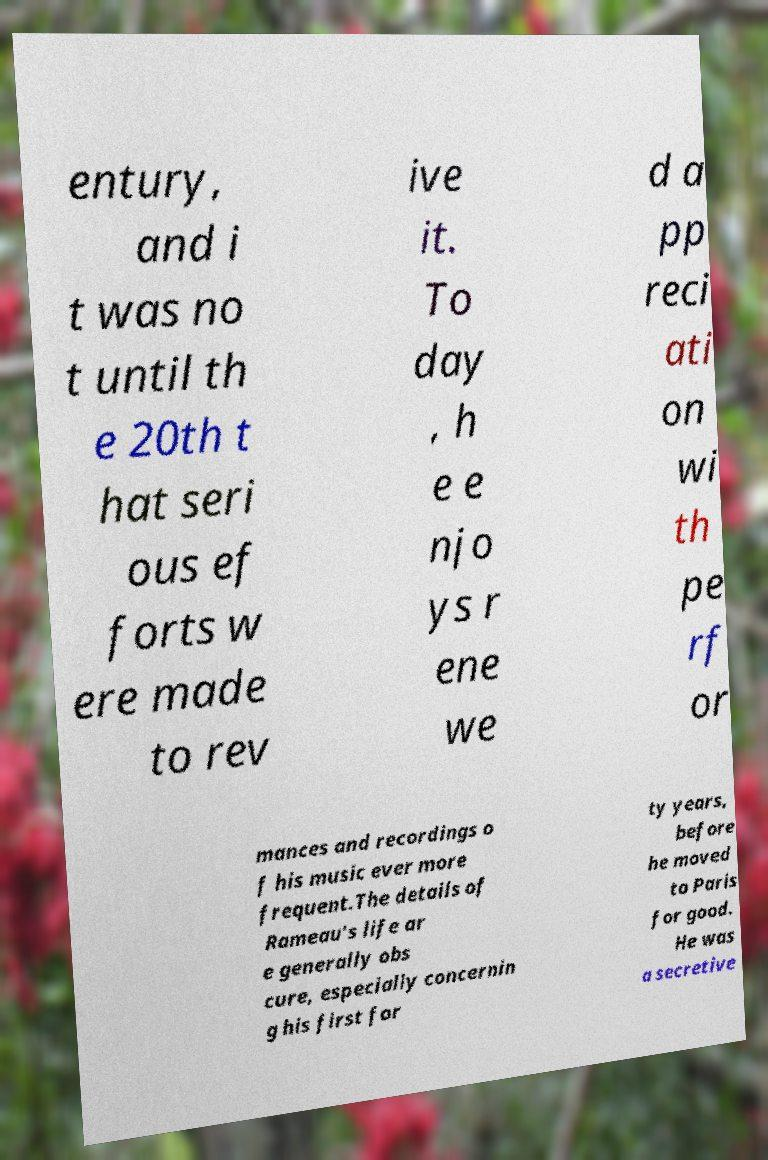What messages or text are displayed in this image? I need them in a readable, typed format. entury, and i t was no t until th e 20th t hat seri ous ef forts w ere made to rev ive it. To day , h e e njo ys r ene we d a pp reci ati on wi th pe rf or mances and recordings o f his music ever more frequent.The details of Rameau's life ar e generally obs cure, especially concernin g his first for ty years, before he moved to Paris for good. He was a secretive 